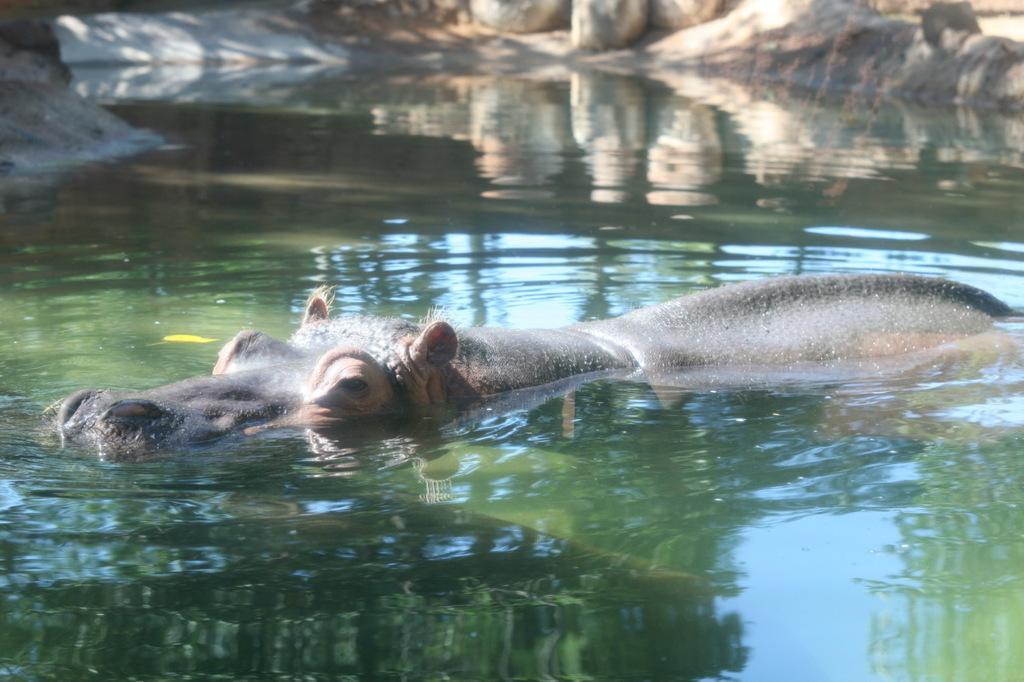In one or two sentences, can you explain what this image depicts? In this image we can see a hippopotamus in the water. On the backside we can see some stones. 